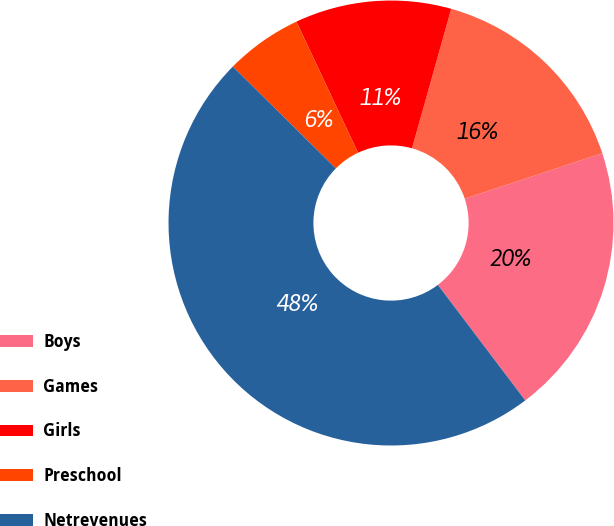Convert chart to OTSL. <chart><loc_0><loc_0><loc_500><loc_500><pie_chart><fcel>Boys<fcel>Games<fcel>Girls<fcel>Preschool<fcel>Netrevenues<nl><fcel>19.77%<fcel>15.56%<fcel>11.35%<fcel>5.6%<fcel>47.72%<nl></chart> 